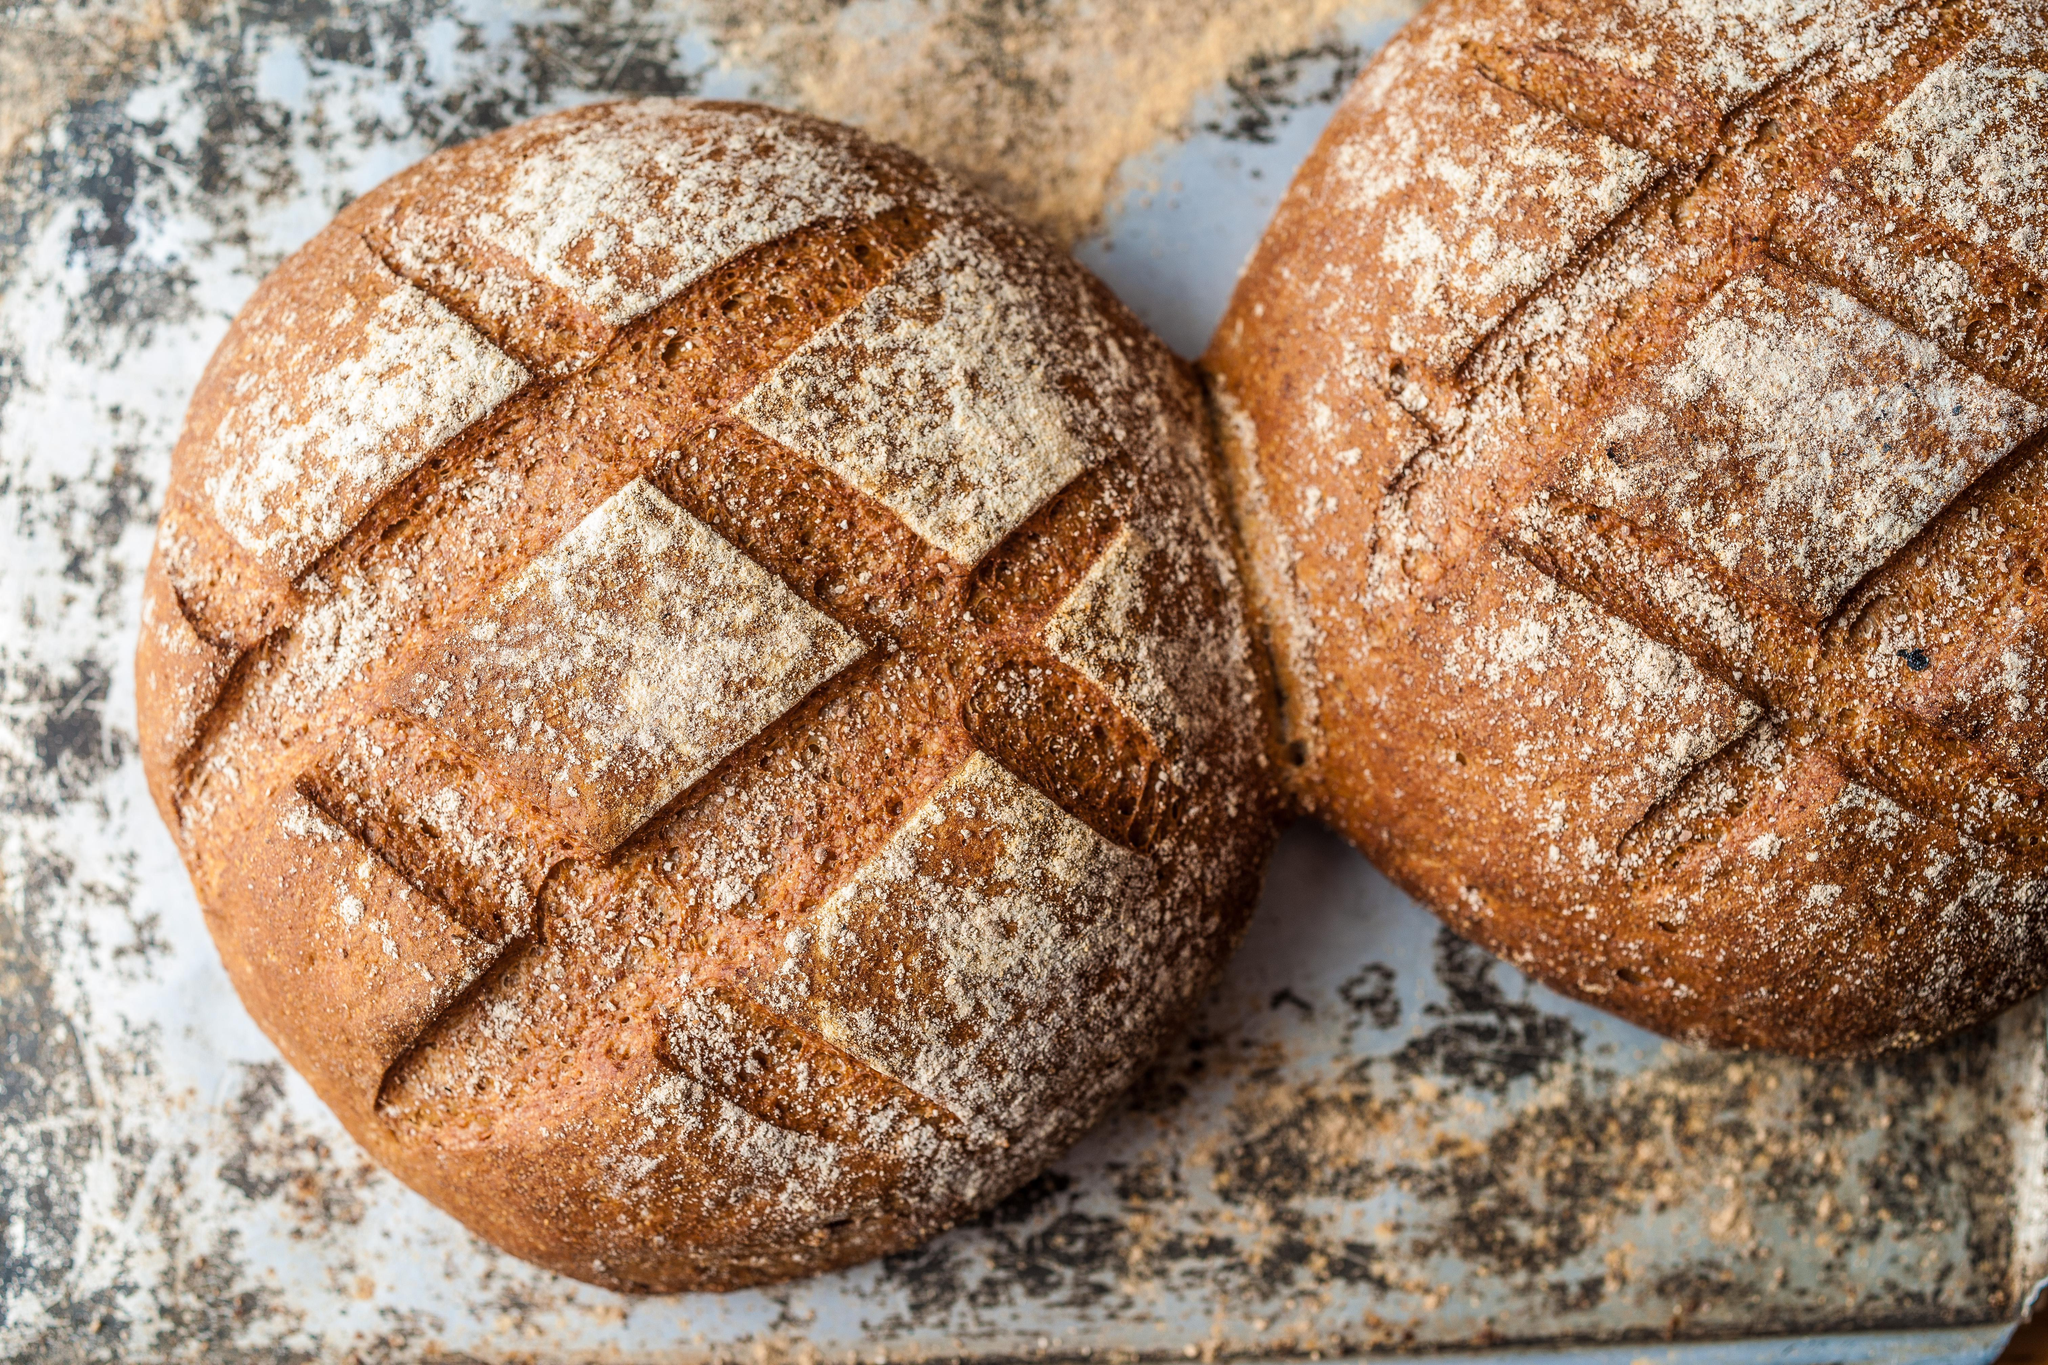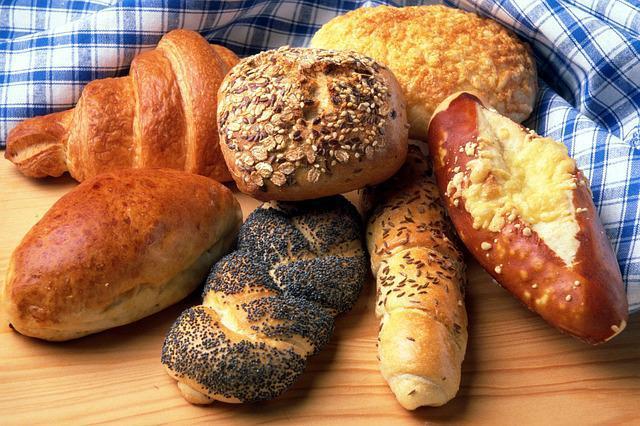The first image is the image on the left, the second image is the image on the right. Analyze the images presented: Is the assertion "None of the bread is cut in at least one of the images." valid? Answer yes or no. Yes. The first image is the image on the left, the second image is the image on the right. For the images shown, is this caption "One of the loaves is placed in an oval dish." true? Answer yes or no. No. 